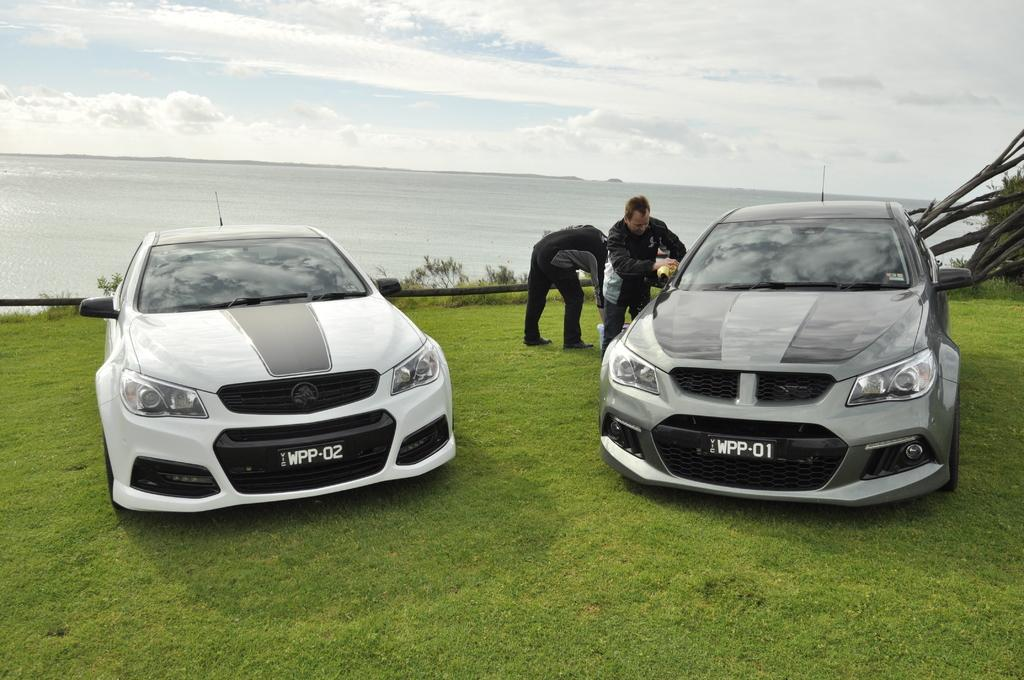How many subjects are present in the image? There are persons and cars in the image. Where are the cars and persons located in the image? The cars and persons are on the grass in the image. What can be seen in the background of the image? Water, sky, and clouds are visible in the background of the image. What type of net is being used to cover the persons in the image? There is no net present in the image, and the persons are not being covered. 